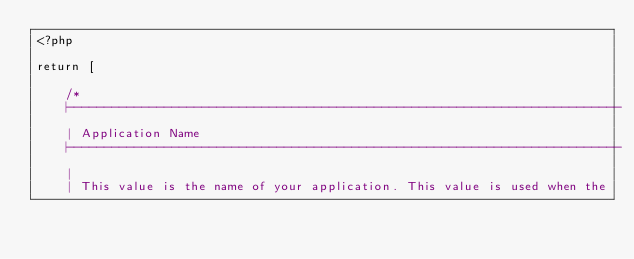Convert code to text. <code><loc_0><loc_0><loc_500><loc_500><_PHP_><?php

return [

    /*
    |--------------------------------------------------------------------------
    | Application Name
    |--------------------------------------------------------------------------
    |
    | This value is the name of your application. This value is used when the</code> 